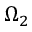Convert formula to latex. <formula><loc_0><loc_0><loc_500><loc_500>\Omega _ { 2 }</formula> 